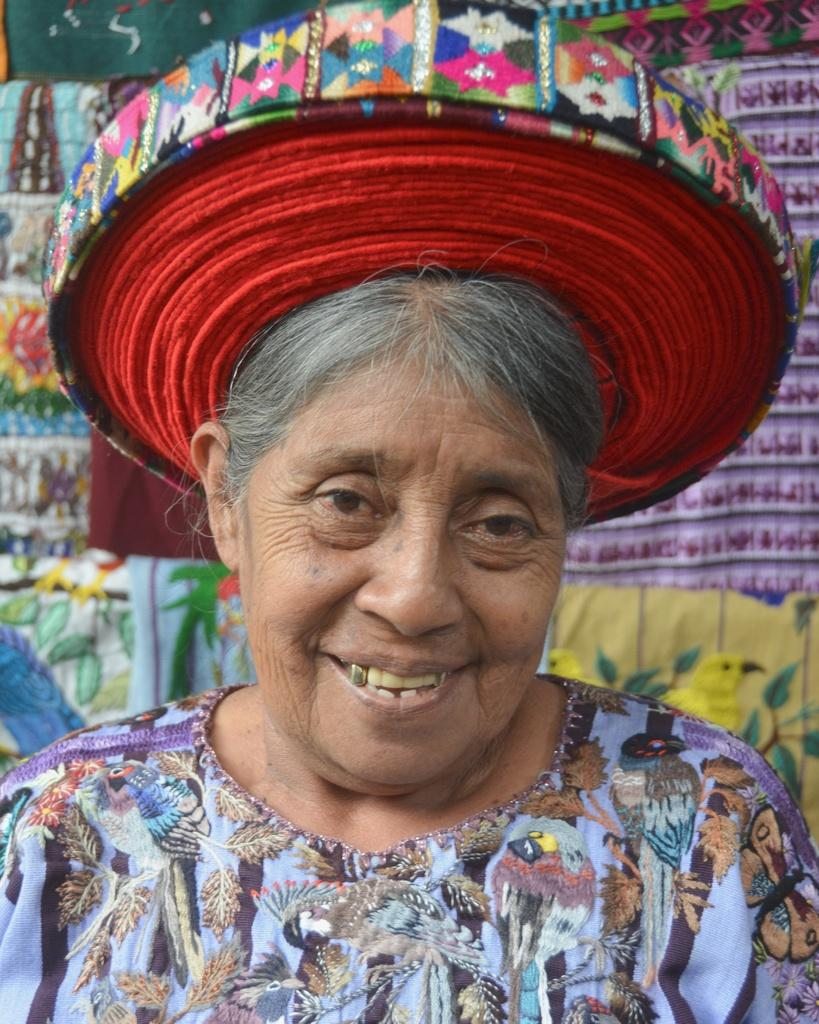Who is present in the image? There is a woman in the image. What is the woman doing in the image? The woman is smiling in the image. What is the woman wearing on her head? The woman is wearing a turban on her head. What can be seen in the background of the image? There are clothes visible in the background of the image. What type of soup is the woman holding in the image? There is no soup present in the image; the woman is not holding anything. 